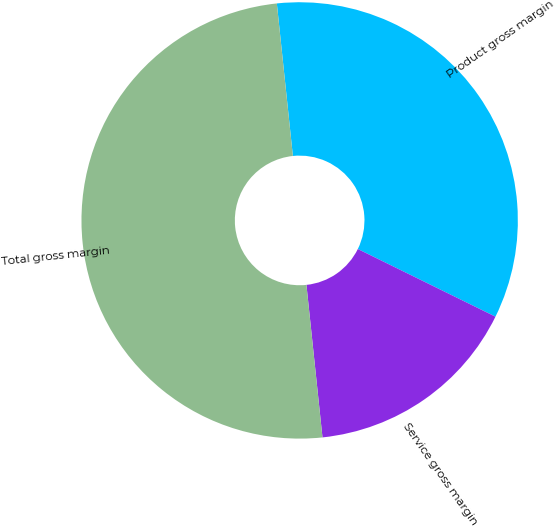Convert chart to OTSL. <chart><loc_0><loc_0><loc_500><loc_500><pie_chart><fcel>Product gross margin<fcel>Service gross margin<fcel>Total gross margin<nl><fcel>33.94%<fcel>16.06%<fcel>50.0%<nl></chart> 